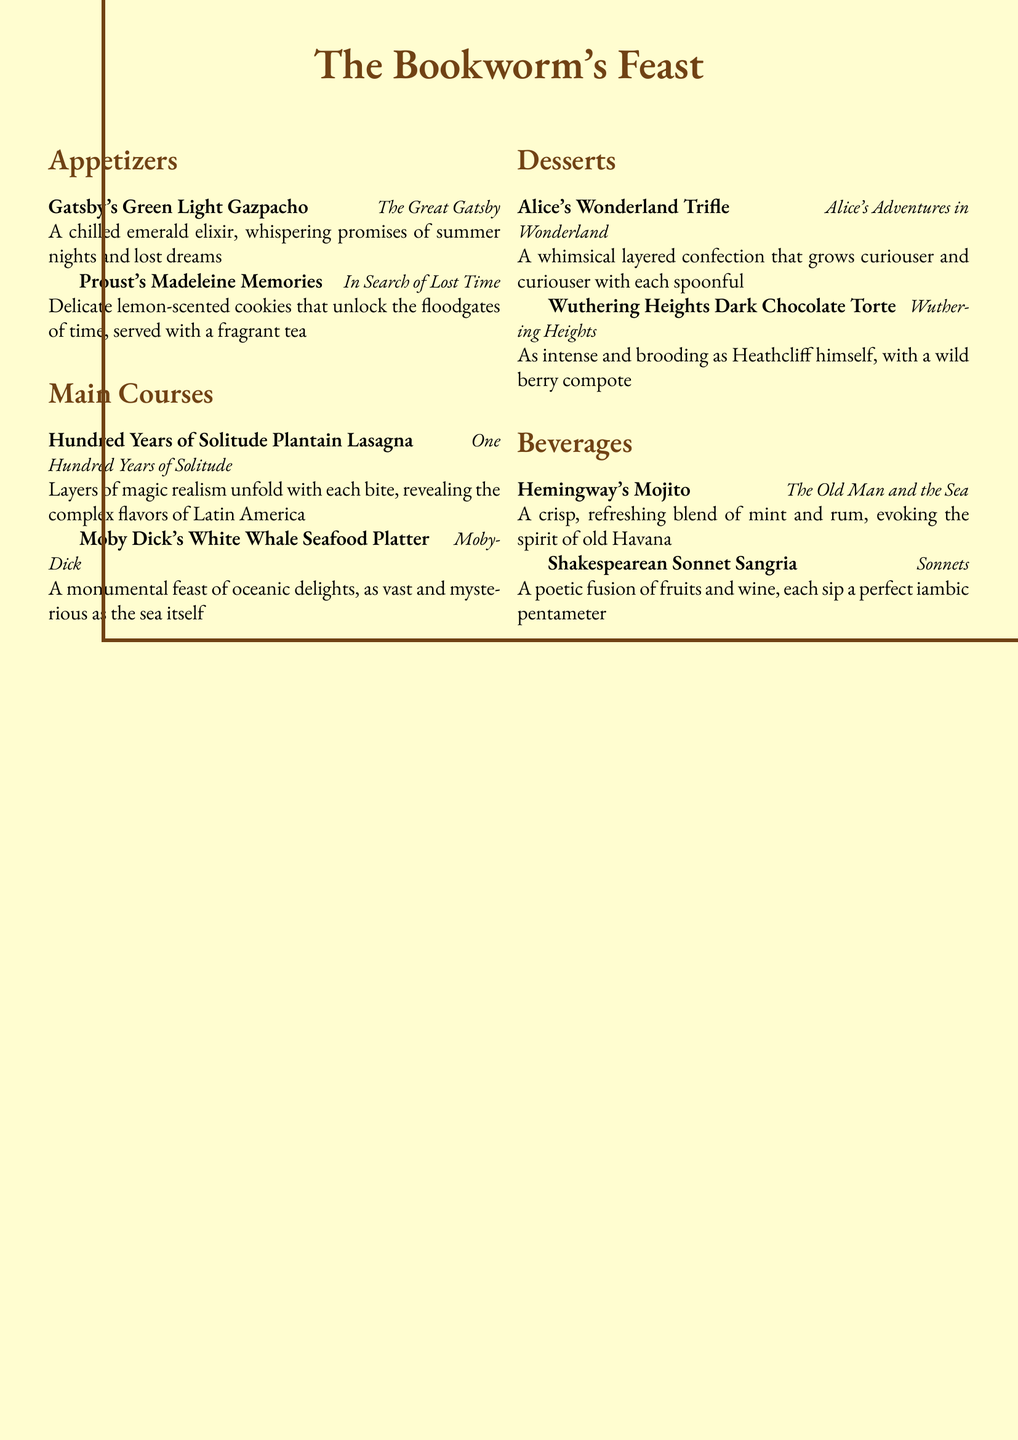What is the title of the menu? The title of the menu is prominently displayed at the top, showcasing its literary theme.
Answer: The Bookworm's Feast How many appetizers are listed? The menu features a section for appetizers, with each item clearly identified.
Answer: 2 What dish is inspired by "Moby-Dick"? One of the main courses directly refers to the classic novel by Herman Melville.
Answer: Moby Dick's White Whale Seafood Platter Which dessert is associated with "Wuthering Heights"? The menu describes a dessert that reflects the intense mood of Emily Brontë's novel.
Answer: Wuthering Heights Dark Chocolate Torte What type of beverage is the "Hemingway's Mojito"? The beverage section includes a refreshing drink inspired by the famous writer and his works.
Answer: Mojito Which appetizer evokes the theme of lost dreams? The description of one appetizer conjures notions of nostalgia and longing, linked to its literary inspiration.
Answer: Gatsby's Green Light Gazpacho What is the primary flavor of the "Proust's Madeleine Memories"? The focus on a specific flavor underscores the connection to the sensory themes in Proust's work.
Answer: Lemon Which dish is described as a “layered confection”? This phrase captures the essence of a whimsical dessert inspired by a beloved children's classic.
Answer: Alice's Wonderland Trifle How does the "Shakespearean Sonnet Sangria" relate to its namesake? The menu describes how the drink mirrors the structure and beauty of Shakespeare's poetic forms.
Answer: Poetic fusion of fruits and wine 